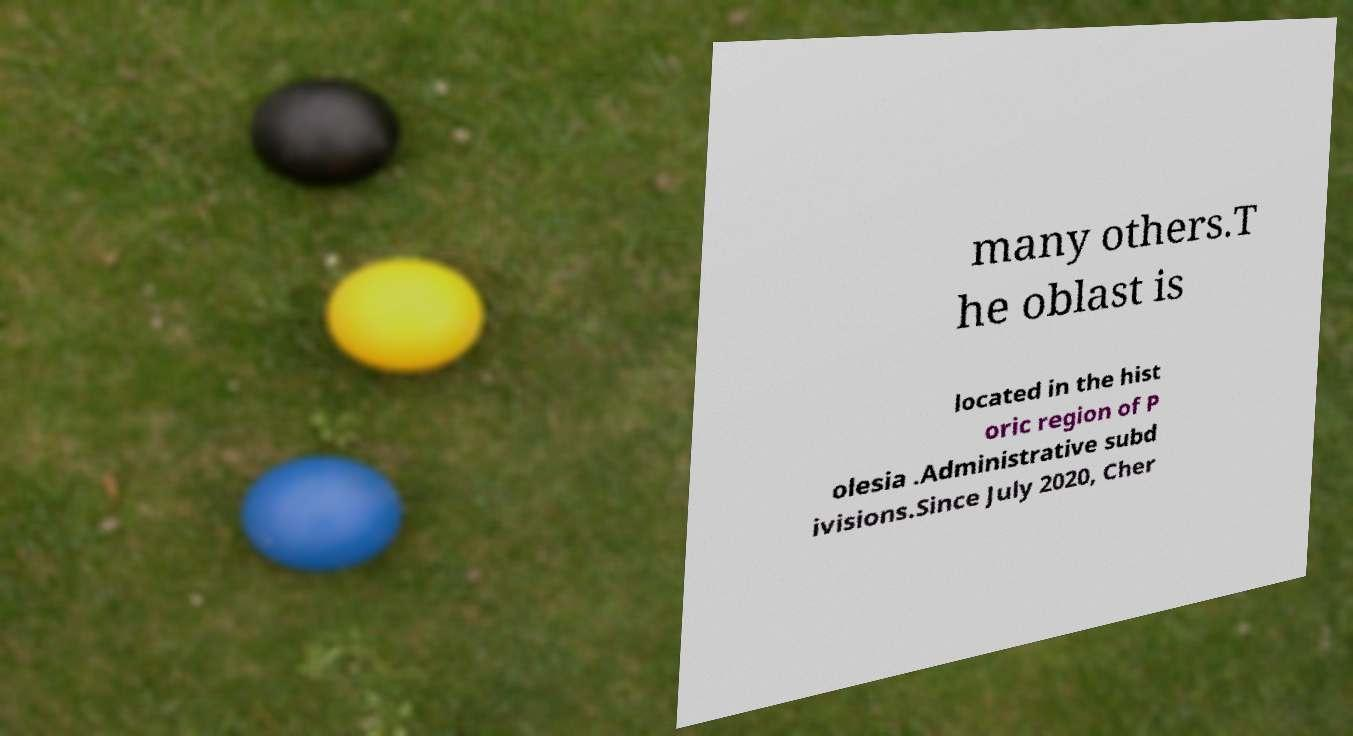What messages or text are displayed in this image? I need them in a readable, typed format. many others.T he oblast is located in the hist oric region of P olesia .Administrative subd ivisions.Since July 2020, Cher 